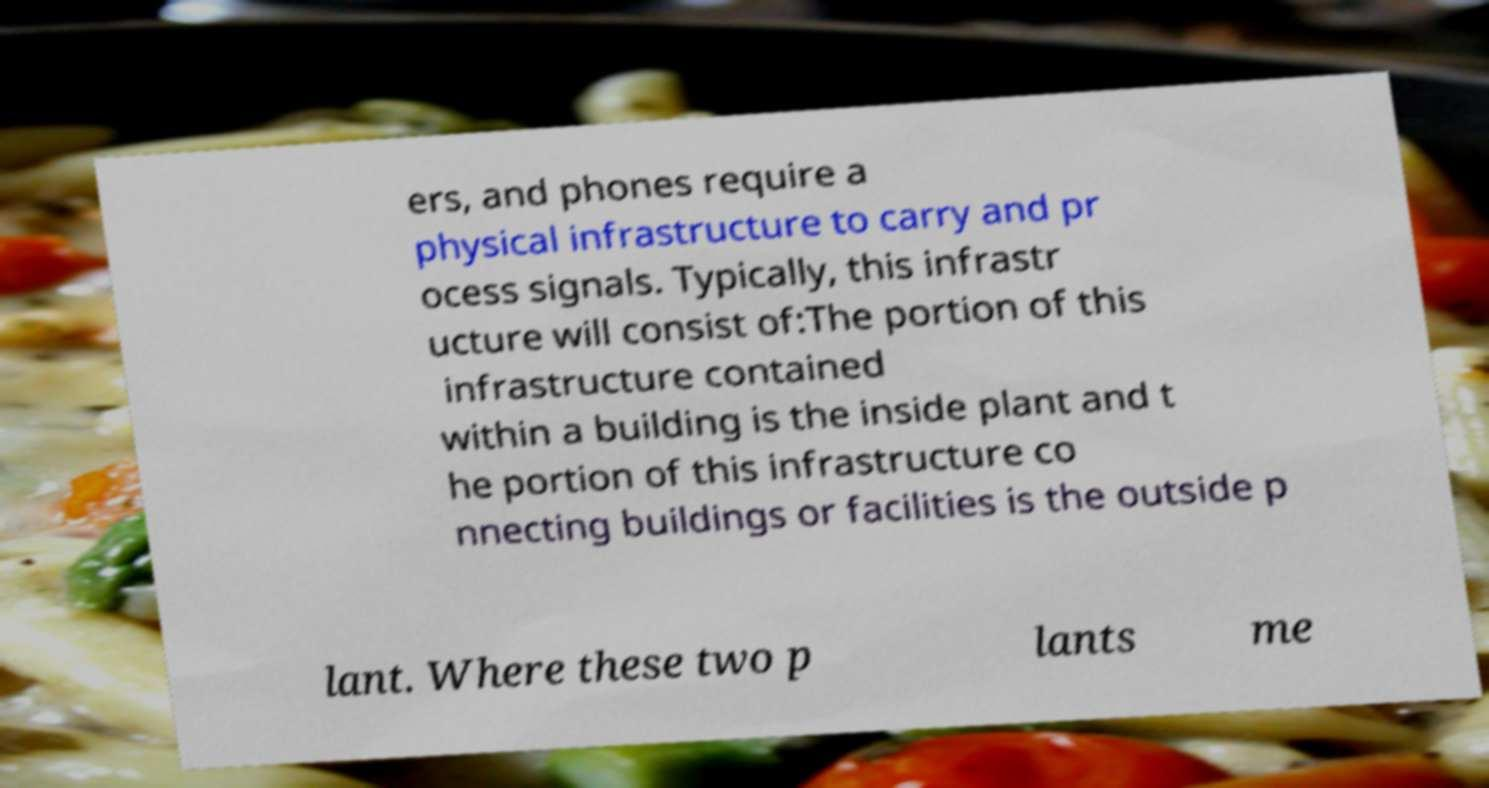There's text embedded in this image that I need extracted. Can you transcribe it verbatim? ers, and phones require a physical infrastructure to carry and pr ocess signals. Typically, this infrastr ucture will consist of:The portion of this infrastructure contained within a building is the inside plant and t he portion of this infrastructure co nnecting buildings or facilities is the outside p lant. Where these two p lants me 